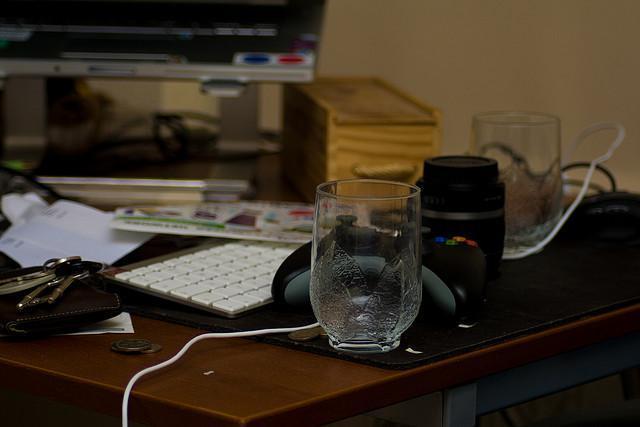What are most keys made of?
Make your selection from the four choices given to correctly answer the question.
Options: Copper, plastic, tin, steel/brass/iron. Steel/brass/iron. 